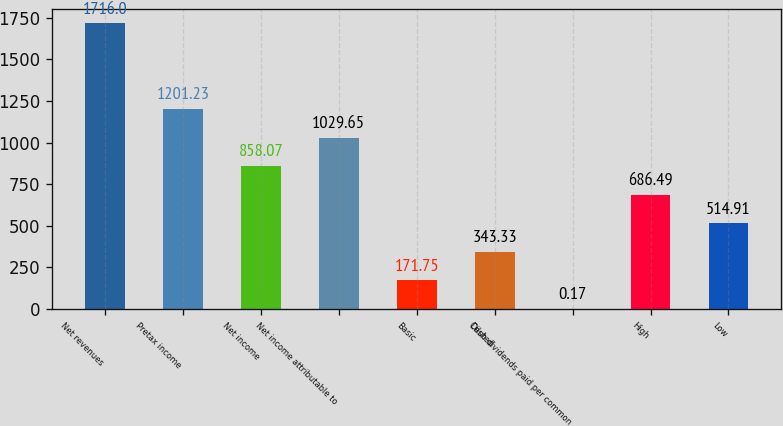<chart> <loc_0><loc_0><loc_500><loc_500><bar_chart><fcel>Net revenues<fcel>Pretax income<fcel>Net income<fcel>Net income attributable to<fcel>Basic<fcel>Diluted<fcel>Cash dividends paid per common<fcel>High<fcel>Low<nl><fcel>1716<fcel>1201.23<fcel>858.07<fcel>1029.65<fcel>171.75<fcel>343.33<fcel>0.17<fcel>686.49<fcel>514.91<nl></chart> 